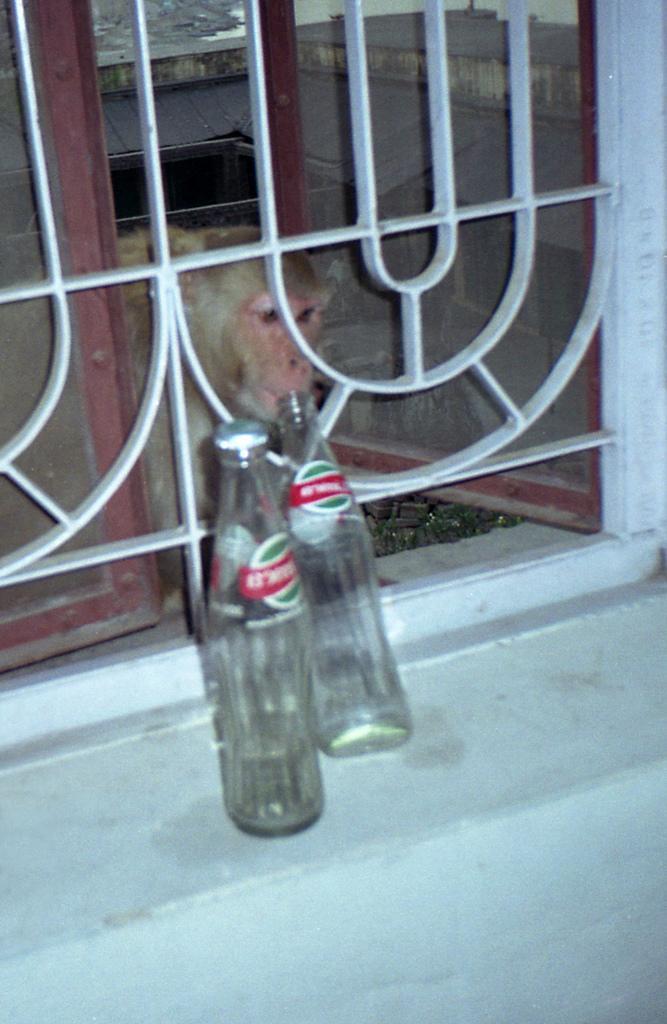In one or two sentences, can you explain what this image depicts? This picture shows a monkey its the window behind window and that two bottles over here 